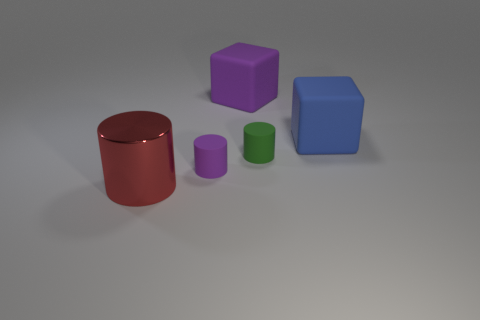Subtract all tiny cylinders. How many cylinders are left? 1 Subtract all purple cubes. How many cubes are left? 1 Add 3 large blue things. How many objects exist? 8 Subtract 1 blocks. How many blocks are left? 1 Subtract all gray cylinders. Subtract all red balls. How many cylinders are left? 3 Subtract all red spheres. How many brown cylinders are left? 0 Subtract all green cylinders. Subtract all big matte things. How many objects are left? 2 Add 4 blue things. How many blue things are left? 5 Add 2 rubber objects. How many rubber objects exist? 6 Subtract 0 gray cylinders. How many objects are left? 5 